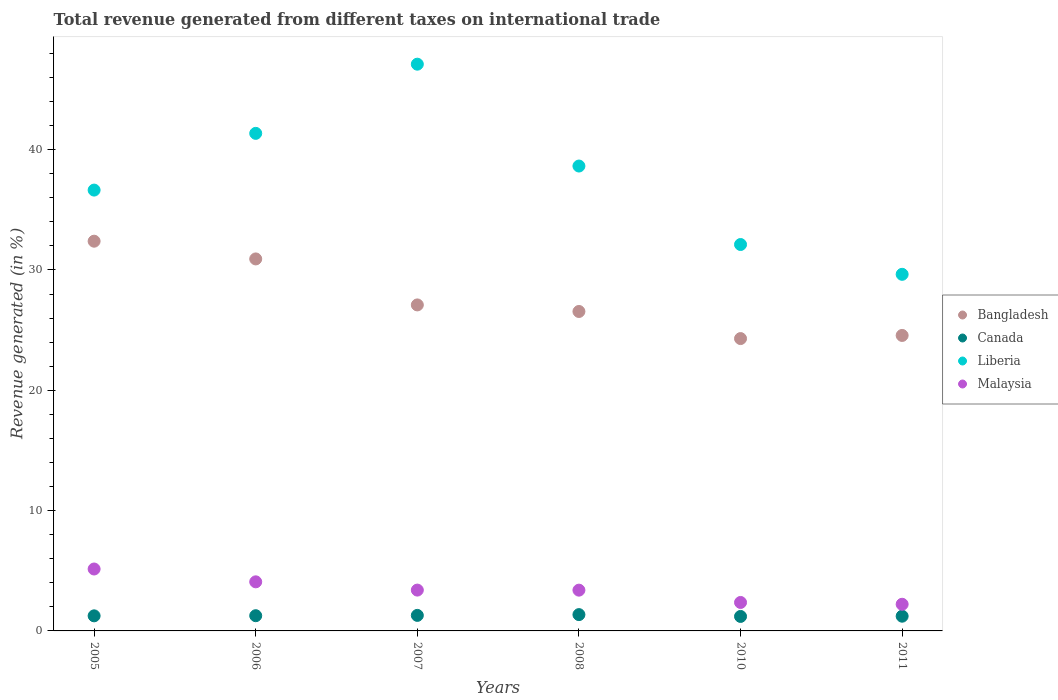How many different coloured dotlines are there?
Your answer should be very brief. 4. Is the number of dotlines equal to the number of legend labels?
Ensure brevity in your answer.  Yes. What is the total revenue generated in Canada in 2010?
Offer a very short reply. 1.2. Across all years, what is the maximum total revenue generated in Bangladesh?
Your answer should be very brief. 32.39. Across all years, what is the minimum total revenue generated in Bangladesh?
Offer a very short reply. 24.3. In which year was the total revenue generated in Canada minimum?
Offer a terse response. 2010. What is the total total revenue generated in Canada in the graph?
Provide a short and direct response. 7.59. What is the difference between the total revenue generated in Canada in 2008 and that in 2011?
Offer a terse response. 0.13. What is the difference between the total revenue generated in Bangladesh in 2011 and the total revenue generated in Liberia in 2005?
Offer a very short reply. -12.08. What is the average total revenue generated in Liberia per year?
Give a very brief answer. 37.58. In the year 2008, what is the difference between the total revenue generated in Canada and total revenue generated in Liberia?
Your answer should be very brief. -37.28. In how many years, is the total revenue generated in Liberia greater than 26 %?
Your answer should be very brief. 6. What is the ratio of the total revenue generated in Malaysia in 2006 to that in 2007?
Your answer should be compact. 1.2. Is the difference between the total revenue generated in Canada in 2005 and 2008 greater than the difference between the total revenue generated in Liberia in 2005 and 2008?
Make the answer very short. Yes. What is the difference between the highest and the second highest total revenue generated in Bangladesh?
Give a very brief answer. 1.47. What is the difference between the highest and the lowest total revenue generated in Liberia?
Your answer should be compact. 17.46. In how many years, is the total revenue generated in Malaysia greater than the average total revenue generated in Malaysia taken over all years?
Give a very brief answer. 2. Is it the case that in every year, the sum of the total revenue generated in Canada and total revenue generated in Malaysia  is greater than the sum of total revenue generated in Bangladesh and total revenue generated in Liberia?
Provide a short and direct response. No. Is it the case that in every year, the sum of the total revenue generated in Bangladesh and total revenue generated in Liberia  is greater than the total revenue generated in Canada?
Offer a terse response. Yes. Is the total revenue generated in Bangladesh strictly less than the total revenue generated in Canada over the years?
Your answer should be very brief. No. How many dotlines are there?
Give a very brief answer. 4. What is the difference between two consecutive major ticks on the Y-axis?
Make the answer very short. 10. Are the values on the major ticks of Y-axis written in scientific E-notation?
Ensure brevity in your answer.  No. Does the graph contain grids?
Make the answer very short. No. How are the legend labels stacked?
Your answer should be compact. Vertical. What is the title of the graph?
Provide a short and direct response. Total revenue generated from different taxes on international trade. Does "Cambodia" appear as one of the legend labels in the graph?
Make the answer very short. No. What is the label or title of the Y-axis?
Provide a succinct answer. Revenue generated (in %). What is the Revenue generated (in %) in Bangladesh in 2005?
Provide a succinct answer. 32.39. What is the Revenue generated (in %) of Canada in 2005?
Your answer should be compact. 1.25. What is the Revenue generated (in %) of Liberia in 2005?
Your answer should be very brief. 36.64. What is the Revenue generated (in %) of Malaysia in 2005?
Offer a terse response. 5.15. What is the Revenue generated (in %) in Bangladesh in 2006?
Give a very brief answer. 30.92. What is the Revenue generated (in %) of Canada in 2006?
Your answer should be compact. 1.26. What is the Revenue generated (in %) of Liberia in 2006?
Keep it short and to the point. 41.35. What is the Revenue generated (in %) in Malaysia in 2006?
Provide a short and direct response. 4.08. What is the Revenue generated (in %) of Bangladesh in 2007?
Your answer should be compact. 27.09. What is the Revenue generated (in %) of Canada in 2007?
Your answer should be very brief. 1.29. What is the Revenue generated (in %) in Liberia in 2007?
Your answer should be compact. 47.1. What is the Revenue generated (in %) in Malaysia in 2007?
Provide a succinct answer. 3.39. What is the Revenue generated (in %) in Bangladesh in 2008?
Provide a succinct answer. 26.55. What is the Revenue generated (in %) in Canada in 2008?
Give a very brief answer. 1.36. What is the Revenue generated (in %) of Liberia in 2008?
Provide a succinct answer. 38.63. What is the Revenue generated (in %) of Malaysia in 2008?
Give a very brief answer. 3.39. What is the Revenue generated (in %) of Bangladesh in 2010?
Your answer should be very brief. 24.3. What is the Revenue generated (in %) in Canada in 2010?
Your response must be concise. 1.2. What is the Revenue generated (in %) in Liberia in 2010?
Provide a succinct answer. 32.11. What is the Revenue generated (in %) of Malaysia in 2010?
Offer a terse response. 2.37. What is the Revenue generated (in %) of Bangladesh in 2011?
Offer a terse response. 24.56. What is the Revenue generated (in %) of Canada in 2011?
Keep it short and to the point. 1.22. What is the Revenue generated (in %) in Liberia in 2011?
Give a very brief answer. 29.64. What is the Revenue generated (in %) in Malaysia in 2011?
Your answer should be compact. 2.21. Across all years, what is the maximum Revenue generated (in %) of Bangladesh?
Your response must be concise. 32.39. Across all years, what is the maximum Revenue generated (in %) of Canada?
Provide a succinct answer. 1.36. Across all years, what is the maximum Revenue generated (in %) in Liberia?
Offer a terse response. 47.1. Across all years, what is the maximum Revenue generated (in %) of Malaysia?
Provide a succinct answer. 5.15. Across all years, what is the minimum Revenue generated (in %) in Bangladesh?
Offer a terse response. 24.3. Across all years, what is the minimum Revenue generated (in %) of Canada?
Keep it short and to the point. 1.2. Across all years, what is the minimum Revenue generated (in %) in Liberia?
Provide a succinct answer. 29.64. Across all years, what is the minimum Revenue generated (in %) in Malaysia?
Offer a terse response. 2.21. What is the total Revenue generated (in %) of Bangladesh in the graph?
Make the answer very short. 165.8. What is the total Revenue generated (in %) in Canada in the graph?
Provide a succinct answer. 7.59. What is the total Revenue generated (in %) of Liberia in the graph?
Your answer should be compact. 225.47. What is the total Revenue generated (in %) in Malaysia in the graph?
Offer a terse response. 20.59. What is the difference between the Revenue generated (in %) in Bangladesh in 2005 and that in 2006?
Make the answer very short. 1.47. What is the difference between the Revenue generated (in %) of Canada in 2005 and that in 2006?
Offer a very short reply. -0.01. What is the difference between the Revenue generated (in %) of Liberia in 2005 and that in 2006?
Your response must be concise. -4.71. What is the difference between the Revenue generated (in %) of Malaysia in 2005 and that in 2006?
Offer a very short reply. 1.07. What is the difference between the Revenue generated (in %) of Bangladesh in 2005 and that in 2007?
Offer a terse response. 5.3. What is the difference between the Revenue generated (in %) in Canada in 2005 and that in 2007?
Make the answer very short. -0.04. What is the difference between the Revenue generated (in %) in Liberia in 2005 and that in 2007?
Your response must be concise. -10.46. What is the difference between the Revenue generated (in %) of Malaysia in 2005 and that in 2007?
Offer a very short reply. 1.75. What is the difference between the Revenue generated (in %) in Bangladesh in 2005 and that in 2008?
Ensure brevity in your answer.  5.84. What is the difference between the Revenue generated (in %) of Canada in 2005 and that in 2008?
Provide a succinct answer. -0.1. What is the difference between the Revenue generated (in %) in Liberia in 2005 and that in 2008?
Make the answer very short. -2. What is the difference between the Revenue generated (in %) of Malaysia in 2005 and that in 2008?
Your answer should be compact. 1.76. What is the difference between the Revenue generated (in %) in Bangladesh in 2005 and that in 2010?
Provide a short and direct response. 8.09. What is the difference between the Revenue generated (in %) in Canada in 2005 and that in 2010?
Your response must be concise. 0.05. What is the difference between the Revenue generated (in %) in Liberia in 2005 and that in 2010?
Provide a short and direct response. 4.52. What is the difference between the Revenue generated (in %) in Malaysia in 2005 and that in 2010?
Provide a short and direct response. 2.78. What is the difference between the Revenue generated (in %) of Bangladesh in 2005 and that in 2011?
Your answer should be compact. 7.83. What is the difference between the Revenue generated (in %) in Canada in 2005 and that in 2011?
Make the answer very short. 0.03. What is the difference between the Revenue generated (in %) in Liberia in 2005 and that in 2011?
Your answer should be very brief. 7. What is the difference between the Revenue generated (in %) in Malaysia in 2005 and that in 2011?
Offer a terse response. 2.93. What is the difference between the Revenue generated (in %) in Bangladesh in 2006 and that in 2007?
Provide a succinct answer. 3.82. What is the difference between the Revenue generated (in %) in Canada in 2006 and that in 2007?
Offer a very short reply. -0.03. What is the difference between the Revenue generated (in %) of Liberia in 2006 and that in 2007?
Offer a very short reply. -5.75. What is the difference between the Revenue generated (in %) of Malaysia in 2006 and that in 2007?
Provide a succinct answer. 0.69. What is the difference between the Revenue generated (in %) in Bangladesh in 2006 and that in 2008?
Offer a terse response. 4.37. What is the difference between the Revenue generated (in %) of Canada in 2006 and that in 2008?
Make the answer very short. -0.09. What is the difference between the Revenue generated (in %) of Liberia in 2006 and that in 2008?
Provide a short and direct response. 2.72. What is the difference between the Revenue generated (in %) of Malaysia in 2006 and that in 2008?
Give a very brief answer. 0.69. What is the difference between the Revenue generated (in %) of Bangladesh in 2006 and that in 2010?
Your response must be concise. 6.62. What is the difference between the Revenue generated (in %) in Canada in 2006 and that in 2010?
Give a very brief answer. 0.06. What is the difference between the Revenue generated (in %) in Liberia in 2006 and that in 2010?
Keep it short and to the point. 9.24. What is the difference between the Revenue generated (in %) of Malaysia in 2006 and that in 2010?
Give a very brief answer. 1.71. What is the difference between the Revenue generated (in %) in Bangladesh in 2006 and that in 2011?
Your answer should be compact. 6.36. What is the difference between the Revenue generated (in %) in Canada in 2006 and that in 2011?
Your response must be concise. 0.04. What is the difference between the Revenue generated (in %) of Liberia in 2006 and that in 2011?
Ensure brevity in your answer.  11.71. What is the difference between the Revenue generated (in %) in Malaysia in 2006 and that in 2011?
Your answer should be compact. 1.86. What is the difference between the Revenue generated (in %) in Bangladesh in 2007 and that in 2008?
Provide a short and direct response. 0.55. What is the difference between the Revenue generated (in %) in Canada in 2007 and that in 2008?
Offer a very short reply. -0.06. What is the difference between the Revenue generated (in %) of Liberia in 2007 and that in 2008?
Your response must be concise. 8.46. What is the difference between the Revenue generated (in %) of Malaysia in 2007 and that in 2008?
Offer a very short reply. 0.01. What is the difference between the Revenue generated (in %) of Bangladesh in 2007 and that in 2010?
Give a very brief answer. 2.8. What is the difference between the Revenue generated (in %) in Canada in 2007 and that in 2010?
Your answer should be compact. 0.09. What is the difference between the Revenue generated (in %) in Liberia in 2007 and that in 2010?
Provide a short and direct response. 14.99. What is the difference between the Revenue generated (in %) of Malaysia in 2007 and that in 2010?
Your answer should be very brief. 1.03. What is the difference between the Revenue generated (in %) in Bangladesh in 2007 and that in 2011?
Give a very brief answer. 2.54. What is the difference between the Revenue generated (in %) in Canada in 2007 and that in 2011?
Offer a terse response. 0.07. What is the difference between the Revenue generated (in %) in Liberia in 2007 and that in 2011?
Your answer should be very brief. 17.46. What is the difference between the Revenue generated (in %) of Malaysia in 2007 and that in 2011?
Provide a succinct answer. 1.18. What is the difference between the Revenue generated (in %) in Bangladesh in 2008 and that in 2010?
Ensure brevity in your answer.  2.25. What is the difference between the Revenue generated (in %) of Canada in 2008 and that in 2010?
Offer a terse response. 0.15. What is the difference between the Revenue generated (in %) of Liberia in 2008 and that in 2010?
Keep it short and to the point. 6.52. What is the difference between the Revenue generated (in %) in Malaysia in 2008 and that in 2010?
Make the answer very short. 1.02. What is the difference between the Revenue generated (in %) in Bangladesh in 2008 and that in 2011?
Provide a short and direct response. 1.99. What is the difference between the Revenue generated (in %) in Canada in 2008 and that in 2011?
Offer a terse response. 0.13. What is the difference between the Revenue generated (in %) in Liberia in 2008 and that in 2011?
Give a very brief answer. 9. What is the difference between the Revenue generated (in %) of Malaysia in 2008 and that in 2011?
Offer a very short reply. 1.17. What is the difference between the Revenue generated (in %) in Bangladesh in 2010 and that in 2011?
Make the answer very short. -0.26. What is the difference between the Revenue generated (in %) of Canada in 2010 and that in 2011?
Offer a very short reply. -0.02. What is the difference between the Revenue generated (in %) of Liberia in 2010 and that in 2011?
Your answer should be very brief. 2.48. What is the difference between the Revenue generated (in %) in Malaysia in 2010 and that in 2011?
Provide a short and direct response. 0.15. What is the difference between the Revenue generated (in %) in Bangladesh in 2005 and the Revenue generated (in %) in Canada in 2006?
Your answer should be very brief. 31.12. What is the difference between the Revenue generated (in %) in Bangladesh in 2005 and the Revenue generated (in %) in Liberia in 2006?
Your answer should be very brief. -8.96. What is the difference between the Revenue generated (in %) in Bangladesh in 2005 and the Revenue generated (in %) in Malaysia in 2006?
Your answer should be compact. 28.31. What is the difference between the Revenue generated (in %) of Canada in 2005 and the Revenue generated (in %) of Liberia in 2006?
Ensure brevity in your answer.  -40.1. What is the difference between the Revenue generated (in %) in Canada in 2005 and the Revenue generated (in %) in Malaysia in 2006?
Provide a short and direct response. -2.83. What is the difference between the Revenue generated (in %) of Liberia in 2005 and the Revenue generated (in %) of Malaysia in 2006?
Your answer should be very brief. 32.56. What is the difference between the Revenue generated (in %) in Bangladesh in 2005 and the Revenue generated (in %) in Canada in 2007?
Offer a very short reply. 31.1. What is the difference between the Revenue generated (in %) of Bangladesh in 2005 and the Revenue generated (in %) of Liberia in 2007?
Ensure brevity in your answer.  -14.71. What is the difference between the Revenue generated (in %) in Bangladesh in 2005 and the Revenue generated (in %) in Malaysia in 2007?
Provide a succinct answer. 29. What is the difference between the Revenue generated (in %) in Canada in 2005 and the Revenue generated (in %) in Liberia in 2007?
Make the answer very short. -45.85. What is the difference between the Revenue generated (in %) in Canada in 2005 and the Revenue generated (in %) in Malaysia in 2007?
Offer a terse response. -2.14. What is the difference between the Revenue generated (in %) in Liberia in 2005 and the Revenue generated (in %) in Malaysia in 2007?
Your answer should be very brief. 33.24. What is the difference between the Revenue generated (in %) of Bangladesh in 2005 and the Revenue generated (in %) of Canada in 2008?
Give a very brief answer. 31.03. What is the difference between the Revenue generated (in %) in Bangladesh in 2005 and the Revenue generated (in %) in Liberia in 2008?
Ensure brevity in your answer.  -6.25. What is the difference between the Revenue generated (in %) of Bangladesh in 2005 and the Revenue generated (in %) of Malaysia in 2008?
Ensure brevity in your answer.  29. What is the difference between the Revenue generated (in %) of Canada in 2005 and the Revenue generated (in %) of Liberia in 2008?
Provide a short and direct response. -37.38. What is the difference between the Revenue generated (in %) in Canada in 2005 and the Revenue generated (in %) in Malaysia in 2008?
Your answer should be very brief. -2.13. What is the difference between the Revenue generated (in %) in Liberia in 2005 and the Revenue generated (in %) in Malaysia in 2008?
Give a very brief answer. 33.25. What is the difference between the Revenue generated (in %) in Bangladesh in 2005 and the Revenue generated (in %) in Canada in 2010?
Provide a short and direct response. 31.18. What is the difference between the Revenue generated (in %) of Bangladesh in 2005 and the Revenue generated (in %) of Liberia in 2010?
Provide a short and direct response. 0.28. What is the difference between the Revenue generated (in %) in Bangladesh in 2005 and the Revenue generated (in %) in Malaysia in 2010?
Your answer should be compact. 30.02. What is the difference between the Revenue generated (in %) in Canada in 2005 and the Revenue generated (in %) in Liberia in 2010?
Offer a very short reply. -30.86. What is the difference between the Revenue generated (in %) of Canada in 2005 and the Revenue generated (in %) of Malaysia in 2010?
Your response must be concise. -1.11. What is the difference between the Revenue generated (in %) in Liberia in 2005 and the Revenue generated (in %) in Malaysia in 2010?
Provide a succinct answer. 34.27. What is the difference between the Revenue generated (in %) of Bangladesh in 2005 and the Revenue generated (in %) of Canada in 2011?
Ensure brevity in your answer.  31.16. What is the difference between the Revenue generated (in %) of Bangladesh in 2005 and the Revenue generated (in %) of Liberia in 2011?
Your response must be concise. 2.75. What is the difference between the Revenue generated (in %) of Bangladesh in 2005 and the Revenue generated (in %) of Malaysia in 2011?
Offer a terse response. 30.17. What is the difference between the Revenue generated (in %) of Canada in 2005 and the Revenue generated (in %) of Liberia in 2011?
Offer a terse response. -28.38. What is the difference between the Revenue generated (in %) in Canada in 2005 and the Revenue generated (in %) in Malaysia in 2011?
Keep it short and to the point. -0.96. What is the difference between the Revenue generated (in %) of Liberia in 2005 and the Revenue generated (in %) of Malaysia in 2011?
Your response must be concise. 34.42. What is the difference between the Revenue generated (in %) in Bangladesh in 2006 and the Revenue generated (in %) in Canada in 2007?
Your answer should be very brief. 29.62. What is the difference between the Revenue generated (in %) in Bangladesh in 2006 and the Revenue generated (in %) in Liberia in 2007?
Give a very brief answer. -16.18. What is the difference between the Revenue generated (in %) in Bangladesh in 2006 and the Revenue generated (in %) in Malaysia in 2007?
Make the answer very short. 27.52. What is the difference between the Revenue generated (in %) in Canada in 2006 and the Revenue generated (in %) in Liberia in 2007?
Your answer should be very brief. -45.83. What is the difference between the Revenue generated (in %) of Canada in 2006 and the Revenue generated (in %) of Malaysia in 2007?
Provide a succinct answer. -2.13. What is the difference between the Revenue generated (in %) of Liberia in 2006 and the Revenue generated (in %) of Malaysia in 2007?
Give a very brief answer. 37.96. What is the difference between the Revenue generated (in %) in Bangladesh in 2006 and the Revenue generated (in %) in Canada in 2008?
Keep it short and to the point. 29.56. What is the difference between the Revenue generated (in %) of Bangladesh in 2006 and the Revenue generated (in %) of Liberia in 2008?
Provide a short and direct response. -7.72. What is the difference between the Revenue generated (in %) of Bangladesh in 2006 and the Revenue generated (in %) of Malaysia in 2008?
Provide a succinct answer. 27.53. What is the difference between the Revenue generated (in %) of Canada in 2006 and the Revenue generated (in %) of Liberia in 2008?
Offer a terse response. -37.37. What is the difference between the Revenue generated (in %) in Canada in 2006 and the Revenue generated (in %) in Malaysia in 2008?
Give a very brief answer. -2.12. What is the difference between the Revenue generated (in %) in Liberia in 2006 and the Revenue generated (in %) in Malaysia in 2008?
Ensure brevity in your answer.  37.96. What is the difference between the Revenue generated (in %) of Bangladesh in 2006 and the Revenue generated (in %) of Canada in 2010?
Offer a very short reply. 29.71. What is the difference between the Revenue generated (in %) of Bangladesh in 2006 and the Revenue generated (in %) of Liberia in 2010?
Provide a succinct answer. -1.2. What is the difference between the Revenue generated (in %) of Bangladesh in 2006 and the Revenue generated (in %) of Malaysia in 2010?
Provide a short and direct response. 28.55. What is the difference between the Revenue generated (in %) of Canada in 2006 and the Revenue generated (in %) of Liberia in 2010?
Provide a succinct answer. -30.85. What is the difference between the Revenue generated (in %) in Canada in 2006 and the Revenue generated (in %) in Malaysia in 2010?
Give a very brief answer. -1.1. What is the difference between the Revenue generated (in %) in Liberia in 2006 and the Revenue generated (in %) in Malaysia in 2010?
Your response must be concise. 38.98. What is the difference between the Revenue generated (in %) in Bangladesh in 2006 and the Revenue generated (in %) in Canada in 2011?
Offer a terse response. 29.69. What is the difference between the Revenue generated (in %) in Bangladesh in 2006 and the Revenue generated (in %) in Liberia in 2011?
Your response must be concise. 1.28. What is the difference between the Revenue generated (in %) of Bangladesh in 2006 and the Revenue generated (in %) of Malaysia in 2011?
Make the answer very short. 28.7. What is the difference between the Revenue generated (in %) of Canada in 2006 and the Revenue generated (in %) of Liberia in 2011?
Provide a succinct answer. -28.37. What is the difference between the Revenue generated (in %) of Canada in 2006 and the Revenue generated (in %) of Malaysia in 2011?
Keep it short and to the point. -0.95. What is the difference between the Revenue generated (in %) of Liberia in 2006 and the Revenue generated (in %) of Malaysia in 2011?
Your answer should be very brief. 39.14. What is the difference between the Revenue generated (in %) in Bangladesh in 2007 and the Revenue generated (in %) in Canada in 2008?
Your answer should be very brief. 25.74. What is the difference between the Revenue generated (in %) in Bangladesh in 2007 and the Revenue generated (in %) in Liberia in 2008?
Make the answer very short. -11.54. What is the difference between the Revenue generated (in %) of Bangladesh in 2007 and the Revenue generated (in %) of Malaysia in 2008?
Your answer should be compact. 23.7. What is the difference between the Revenue generated (in %) in Canada in 2007 and the Revenue generated (in %) in Liberia in 2008?
Your answer should be compact. -37.34. What is the difference between the Revenue generated (in %) in Canada in 2007 and the Revenue generated (in %) in Malaysia in 2008?
Ensure brevity in your answer.  -2.1. What is the difference between the Revenue generated (in %) in Liberia in 2007 and the Revenue generated (in %) in Malaysia in 2008?
Keep it short and to the point. 43.71. What is the difference between the Revenue generated (in %) in Bangladesh in 2007 and the Revenue generated (in %) in Canada in 2010?
Offer a terse response. 25.89. What is the difference between the Revenue generated (in %) in Bangladesh in 2007 and the Revenue generated (in %) in Liberia in 2010?
Make the answer very short. -5.02. What is the difference between the Revenue generated (in %) in Bangladesh in 2007 and the Revenue generated (in %) in Malaysia in 2010?
Offer a terse response. 24.73. What is the difference between the Revenue generated (in %) of Canada in 2007 and the Revenue generated (in %) of Liberia in 2010?
Your answer should be compact. -30.82. What is the difference between the Revenue generated (in %) of Canada in 2007 and the Revenue generated (in %) of Malaysia in 2010?
Your response must be concise. -1.07. What is the difference between the Revenue generated (in %) of Liberia in 2007 and the Revenue generated (in %) of Malaysia in 2010?
Make the answer very short. 44.73. What is the difference between the Revenue generated (in %) in Bangladesh in 2007 and the Revenue generated (in %) in Canada in 2011?
Keep it short and to the point. 25.87. What is the difference between the Revenue generated (in %) of Bangladesh in 2007 and the Revenue generated (in %) of Liberia in 2011?
Keep it short and to the point. -2.54. What is the difference between the Revenue generated (in %) of Bangladesh in 2007 and the Revenue generated (in %) of Malaysia in 2011?
Your answer should be very brief. 24.88. What is the difference between the Revenue generated (in %) of Canada in 2007 and the Revenue generated (in %) of Liberia in 2011?
Keep it short and to the point. -28.34. What is the difference between the Revenue generated (in %) of Canada in 2007 and the Revenue generated (in %) of Malaysia in 2011?
Give a very brief answer. -0.92. What is the difference between the Revenue generated (in %) of Liberia in 2007 and the Revenue generated (in %) of Malaysia in 2011?
Your answer should be very brief. 44.88. What is the difference between the Revenue generated (in %) in Bangladesh in 2008 and the Revenue generated (in %) in Canada in 2010?
Give a very brief answer. 25.34. What is the difference between the Revenue generated (in %) in Bangladesh in 2008 and the Revenue generated (in %) in Liberia in 2010?
Your answer should be compact. -5.57. What is the difference between the Revenue generated (in %) in Bangladesh in 2008 and the Revenue generated (in %) in Malaysia in 2010?
Your answer should be very brief. 24.18. What is the difference between the Revenue generated (in %) of Canada in 2008 and the Revenue generated (in %) of Liberia in 2010?
Your answer should be compact. -30.76. What is the difference between the Revenue generated (in %) in Canada in 2008 and the Revenue generated (in %) in Malaysia in 2010?
Your response must be concise. -1.01. What is the difference between the Revenue generated (in %) in Liberia in 2008 and the Revenue generated (in %) in Malaysia in 2010?
Your answer should be very brief. 36.27. What is the difference between the Revenue generated (in %) in Bangladesh in 2008 and the Revenue generated (in %) in Canada in 2011?
Your answer should be compact. 25.32. What is the difference between the Revenue generated (in %) of Bangladesh in 2008 and the Revenue generated (in %) of Liberia in 2011?
Your answer should be compact. -3.09. What is the difference between the Revenue generated (in %) of Bangladesh in 2008 and the Revenue generated (in %) of Malaysia in 2011?
Make the answer very short. 24.33. What is the difference between the Revenue generated (in %) in Canada in 2008 and the Revenue generated (in %) in Liberia in 2011?
Ensure brevity in your answer.  -28.28. What is the difference between the Revenue generated (in %) of Canada in 2008 and the Revenue generated (in %) of Malaysia in 2011?
Your response must be concise. -0.86. What is the difference between the Revenue generated (in %) of Liberia in 2008 and the Revenue generated (in %) of Malaysia in 2011?
Offer a terse response. 36.42. What is the difference between the Revenue generated (in %) of Bangladesh in 2010 and the Revenue generated (in %) of Canada in 2011?
Your answer should be compact. 23.07. What is the difference between the Revenue generated (in %) in Bangladesh in 2010 and the Revenue generated (in %) in Liberia in 2011?
Your answer should be very brief. -5.34. What is the difference between the Revenue generated (in %) in Bangladesh in 2010 and the Revenue generated (in %) in Malaysia in 2011?
Your answer should be very brief. 22.08. What is the difference between the Revenue generated (in %) in Canada in 2010 and the Revenue generated (in %) in Liberia in 2011?
Provide a short and direct response. -28.43. What is the difference between the Revenue generated (in %) of Canada in 2010 and the Revenue generated (in %) of Malaysia in 2011?
Keep it short and to the point. -1.01. What is the difference between the Revenue generated (in %) in Liberia in 2010 and the Revenue generated (in %) in Malaysia in 2011?
Make the answer very short. 29.9. What is the average Revenue generated (in %) of Bangladesh per year?
Provide a short and direct response. 27.63. What is the average Revenue generated (in %) of Canada per year?
Provide a succinct answer. 1.27. What is the average Revenue generated (in %) of Liberia per year?
Keep it short and to the point. 37.58. What is the average Revenue generated (in %) in Malaysia per year?
Provide a short and direct response. 3.43. In the year 2005, what is the difference between the Revenue generated (in %) of Bangladesh and Revenue generated (in %) of Canada?
Your answer should be very brief. 31.14. In the year 2005, what is the difference between the Revenue generated (in %) in Bangladesh and Revenue generated (in %) in Liberia?
Your answer should be very brief. -4.25. In the year 2005, what is the difference between the Revenue generated (in %) in Bangladesh and Revenue generated (in %) in Malaysia?
Provide a short and direct response. 27.24. In the year 2005, what is the difference between the Revenue generated (in %) of Canada and Revenue generated (in %) of Liberia?
Your answer should be very brief. -35.38. In the year 2005, what is the difference between the Revenue generated (in %) in Canada and Revenue generated (in %) in Malaysia?
Provide a short and direct response. -3.89. In the year 2005, what is the difference between the Revenue generated (in %) of Liberia and Revenue generated (in %) of Malaysia?
Keep it short and to the point. 31.49. In the year 2006, what is the difference between the Revenue generated (in %) in Bangladesh and Revenue generated (in %) in Canada?
Your response must be concise. 29.65. In the year 2006, what is the difference between the Revenue generated (in %) of Bangladesh and Revenue generated (in %) of Liberia?
Your answer should be compact. -10.44. In the year 2006, what is the difference between the Revenue generated (in %) in Bangladesh and Revenue generated (in %) in Malaysia?
Ensure brevity in your answer.  26.84. In the year 2006, what is the difference between the Revenue generated (in %) in Canada and Revenue generated (in %) in Liberia?
Keep it short and to the point. -40.09. In the year 2006, what is the difference between the Revenue generated (in %) of Canada and Revenue generated (in %) of Malaysia?
Make the answer very short. -2.82. In the year 2006, what is the difference between the Revenue generated (in %) of Liberia and Revenue generated (in %) of Malaysia?
Provide a short and direct response. 37.27. In the year 2007, what is the difference between the Revenue generated (in %) of Bangladesh and Revenue generated (in %) of Canada?
Offer a very short reply. 25.8. In the year 2007, what is the difference between the Revenue generated (in %) in Bangladesh and Revenue generated (in %) in Liberia?
Offer a terse response. -20.01. In the year 2007, what is the difference between the Revenue generated (in %) in Bangladesh and Revenue generated (in %) in Malaysia?
Ensure brevity in your answer.  23.7. In the year 2007, what is the difference between the Revenue generated (in %) in Canada and Revenue generated (in %) in Liberia?
Your answer should be compact. -45.81. In the year 2007, what is the difference between the Revenue generated (in %) in Canada and Revenue generated (in %) in Malaysia?
Your answer should be compact. -2.1. In the year 2007, what is the difference between the Revenue generated (in %) in Liberia and Revenue generated (in %) in Malaysia?
Your response must be concise. 43.71. In the year 2008, what is the difference between the Revenue generated (in %) in Bangladesh and Revenue generated (in %) in Canada?
Make the answer very short. 25.19. In the year 2008, what is the difference between the Revenue generated (in %) of Bangladesh and Revenue generated (in %) of Liberia?
Your answer should be very brief. -12.09. In the year 2008, what is the difference between the Revenue generated (in %) of Bangladesh and Revenue generated (in %) of Malaysia?
Keep it short and to the point. 23.16. In the year 2008, what is the difference between the Revenue generated (in %) of Canada and Revenue generated (in %) of Liberia?
Offer a terse response. -37.28. In the year 2008, what is the difference between the Revenue generated (in %) in Canada and Revenue generated (in %) in Malaysia?
Provide a short and direct response. -2.03. In the year 2008, what is the difference between the Revenue generated (in %) in Liberia and Revenue generated (in %) in Malaysia?
Make the answer very short. 35.25. In the year 2010, what is the difference between the Revenue generated (in %) of Bangladesh and Revenue generated (in %) of Canada?
Your answer should be compact. 23.09. In the year 2010, what is the difference between the Revenue generated (in %) of Bangladesh and Revenue generated (in %) of Liberia?
Your answer should be compact. -7.82. In the year 2010, what is the difference between the Revenue generated (in %) in Bangladesh and Revenue generated (in %) in Malaysia?
Your answer should be very brief. 21.93. In the year 2010, what is the difference between the Revenue generated (in %) in Canada and Revenue generated (in %) in Liberia?
Ensure brevity in your answer.  -30.91. In the year 2010, what is the difference between the Revenue generated (in %) in Canada and Revenue generated (in %) in Malaysia?
Offer a terse response. -1.16. In the year 2010, what is the difference between the Revenue generated (in %) of Liberia and Revenue generated (in %) of Malaysia?
Your response must be concise. 29.75. In the year 2011, what is the difference between the Revenue generated (in %) in Bangladesh and Revenue generated (in %) in Canada?
Your response must be concise. 23.33. In the year 2011, what is the difference between the Revenue generated (in %) in Bangladesh and Revenue generated (in %) in Liberia?
Ensure brevity in your answer.  -5.08. In the year 2011, what is the difference between the Revenue generated (in %) of Bangladesh and Revenue generated (in %) of Malaysia?
Make the answer very short. 22.34. In the year 2011, what is the difference between the Revenue generated (in %) of Canada and Revenue generated (in %) of Liberia?
Make the answer very short. -28.41. In the year 2011, what is the difference between the Revenue generated (in %) in Canada and Revenue generated (in %) in Malaysia?
Provide a succinct answer. -0.99. In the year 2011, what is the difference between the Revenue generated (in %) of Liberia and Revenue generated (in %) of Malaysia?
Provide a succinct answer. 27.42. What is the ratio of the Revenue generated (in %) of Bangladesh in 2005 to that in 2006?
Give a very brief answer. 1.05. What is the ratio of the Revenue generated (in %) in Liberia in 2005 to that in 2006?
Offer a terse response. 0.89. What is the ratio of the Revenue generated (in %) of Malaysia in 2005 to that in 2006?
Keep it short and to the point. 1.26. What is the ratio of the Revenue generated (in %) of Bangladesh in 2005 to that in 2007?
Offer a very short reply. 1.2. What is the ratio of the Revenue generated (in %) in Canada in 2005 to that in 2007?
Provide a short and direct response. 0.97. What is the ratio of the Revenue generated (in %) in Malaysia in 2005 to that in 2007?
Give a very brief answer. 1.52. What is the ratio of the Revenue generated (in %) of Bangladesh in 2005 to that in 2008?
Make the answer very short. 1.22. What is the ratio of the Revenue generated (in %) of Canada in 2005 to that in 2008?
Give a very brief answer. 0.92. What is the ratio of the Revenue generated (in %) in Liberia in 2005 to that in 2008?
Offer a very short reply. 0.95. What is the ratio of the Revenue generated (in %) in Malaysia in 2005 to that in 2008?
Give a very brief answer. 1.52. What is the ratio of the Revenue generated (in %) in Bangladesh in 2005 to that in 2010?
Give a very brief answer. 1.33. What is the ratio of the Revenue generated (in %) of Canada in 2005 to that in 2010?
Ensure brevity in your answer.  1.04. What is the ratio of the Revenue generated (in %) in Liberia in 2005 to that in 2010?
Give a very brief answer. 1.14. What is the ratio of the Revenue generated (in %) of Malaysia in 2005 to that in 2010?
Keep it short and to the point. 2.18. What is the ratio of the Revenue generated (in %) of Bangladesh in 2005 to that in 2011?
Give a very brief answer. 1.32. What is the ratio of the Revenue generated (in %) in Canada in 2005 to that in 2011?
Give a very brief answer. 1.02. What is the ratio of the Revenue generated (in %) in Liberia in 2005 to that in 2011?
Provide a short and direct response. 1.24. What is the ratio of the Revenue generated (in %) in Malaysia in 2005 to that in 2011?
Your answer should be very brief. 2.32. What is the ratio of the Revenue generated (in %) in Bangladesh in 2006 to that in 2007?
Offer a terse response. 1.14. What is the ratio of the Revenue generated (in %) of Canada in 2006 to that in 2007?
Make the answer very short. 0.98. What is the ratio of the Revenue generated (in %) of Liberia in 2006 to that in 2007?
Keep it short and to the point. 0.88. What is the ratio of the Revenue generated (in %) of Malaysia in 2006 to that in 2007?
Your answer should be very brief. 1.2. What is the ratio of the Revenue generated (in %) of Bangladesh in 2006 to that in 2008?
Your answer should be very brief. 1.16. What is the ratio of the Revenue generated (in %) of Canada in 2006 to that in 2008?
Offer a terse response. 0.93. What is the ratio of the Revenue generated (in %) of Liberia in 2006 to that in 2008?
Give a very brief answer. 1.07. What is the ratio of the Revenue generated (in %) in Malaysia in 2006 to that in 2008?
Your answer should be compact. 1.2. What is the ratio of the Revenue generated (in %) in Bangladesh in 2006 to that in 2010?
Your answer should be very brief. 1.27. What is the ratio of the Revenue generated (in %) of Canada in 2006 to that in 2010?
Keep it short and to the point. 1.05. What is the ratio of the Revenue generated (in %) in Liberia in 2006 to that in 2010?
Offer a terse response. 1.29. What is the ratio of the Revenue generated (in %) of Malaysia in 2006 to that in 2010?
Offer a very short reply. 1.72. What is the ratio of the Revenue generated (in %) in Bangladesh in 2006 to that in 2011?
Your answer should be compact. 1.26. What is the ratio of the Revenue generated (in %) of Canada in 2006 to that in 2011?
Give a very brief answer. 1.03. What is the ratio of the Revenue generated (in %) in Liberia in 2006 to that in 2011?
Provide a succinct answer. 1.4. What is the ratio of the Revenue generated (in %) of Malaysia in 2006 to that in 2011?
Your response must be concise. 1.84. What is the ratio of the Revenue generated (in %) in Bangladesh in 2007 to that in 2008?
Your response must be concise. 1.02. What is the ratio of the Revenue generated (in %) in Canada in 2007 to that in 2008?
Ensure brevity in your answer.  0.95. What is the ratio of the Revenue generated (in %) in Liberia in 2007 to that in 2008?
Provide a succinct answer. 1.22. What is the ratio of the Revenue generated (in %) in Malaysia in 2007 to that in 2008?
Make the answer very short. 1. What is the ratio of the Revenue generated (in %) of Bangladesh in 2007 to that in 2010?
Ensure brevity in your answer.  1.12. What is the ratio of the Revenue generated (in %) in Canada in 2007 to that in 2010?
Keep it short and to the point. 1.07. What is the ratio of the Revenue generated (in %) in Liberia in 2007 to that in 2010?
Offer a terse response. 1.47. What is the ratio of the Revenue generated (in %) of Malaysia in 2007 to that in 2010?
Your answer should be compact. 1.43. What is the ratio of the Revenue generated (in %) in Bangladesh in 2007 to that in 2011?
Offer a very short reply. 1.1. What is the ratio of the Revenue generated (in %) in Canada in 2007 to that in 2011?
Provide a short and direct response. 1.05. What is the ratio of the Revenue generated (in %) in Liberia in 2007 to that in 2011?
Give a very brief answer. 1.59. What is the ratio of the Revenue generated (in %) in Malaysia in 2007 to that in 2011?
Offer a terse response. 1.53. What is the ratio of the Revenue generated (in %) of Bangladesh in 2008 to that in 2010?
Your answer should be very brief. 1.09. What is the ratio of the Revenue generated (in %) of Canada in 2008 to that in 2010?
Give a very brief answer. 1.13. What is the ratio of the Revenue generated (in %) of Liberia in 2008 to that in 2010?
Offer a terse response. 1.2. What is the ratio of the Revenue generated (in %) of Malaysia in 2008 to that in 2010?
Provide a short and direct response. 1.43. What is the ratio of the Revenue generated (in %) of Bangladesh in 2008 to that in 2011?
Provide a short and direct response. 1.08. What is the ratio of the Revenue generated (in %) in Canada in 2008 to that in 2011?
Ensure brevity in your answer.  1.11. What is the ratio of the Revenue generated (in %) of Liberia in 2008 to that in 2011?
Provide a short and direct response. 1.3. What is the ratio of the Revenue generated (in %) in Malaysia in 2008 to that in 2011?
Make the answer very short. 1.53. What is the ratio of the Revenue generated (in %) of Bangladesh in 2010 to that in 2011?
Give a very brief answer. 0.99. What is the ratio of the Revenue generated (in %) in Canada in 2010 to that in 2011?
Your response must be concise. 0.98. What is the ratio of the Revenue generated (in %) of Liberia in 2010 to that in 2011?
Offer a very short reply. 1.08. What is the ratio of the Revenue generated (in %) of Malaysia in 2010 to that in 2011?
Your answer should be very brief. 1.07. What is the difference between the highest and the second highest Revenue generated (in %) of Bangladesh?
Offer a terse response. 1.47. What is the difference between the highest and the second highest Revenue generated (in %) of Canada?
Provide a succinct answer. 0.06. What is the difference between the highest and the second highest Revenue generated (in %) in Liberia?
Ensure brevity in your answer.  5.75. What is the difference between the highest and the second highest Revenue generated (in %) of Malaysia?
Your response must be concise. 1.07. What is the difference between the highest and the lowest Revenue generated (in %) in Bangladesh?
Provide a short and direct response. 8.09. What is the difference between the highest and the lowest Revenue generated (in %) of Canada?
Your answer should be very brief. 0.15. What is the difference between the highest and the lowest Revenue generated (in %) in Liberia?
Give a very brief answer. 17.46. What is the difference between the highest and the lowest Revenue generated (in %) of Malaysia?
Your answer should be very brief. 2.93. 